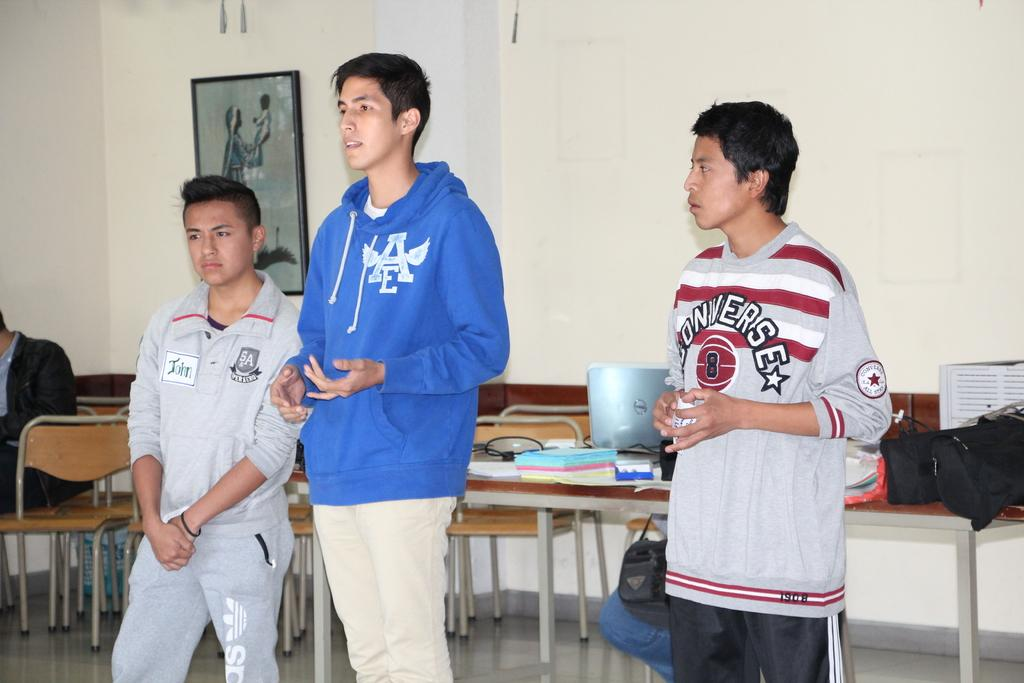<image>
Offer a succinct explanation of the picture presented. A man in a Converse shirt, a man wearing a AE hoddie, and someone with a nametag labeled John are all standing next to each other. 